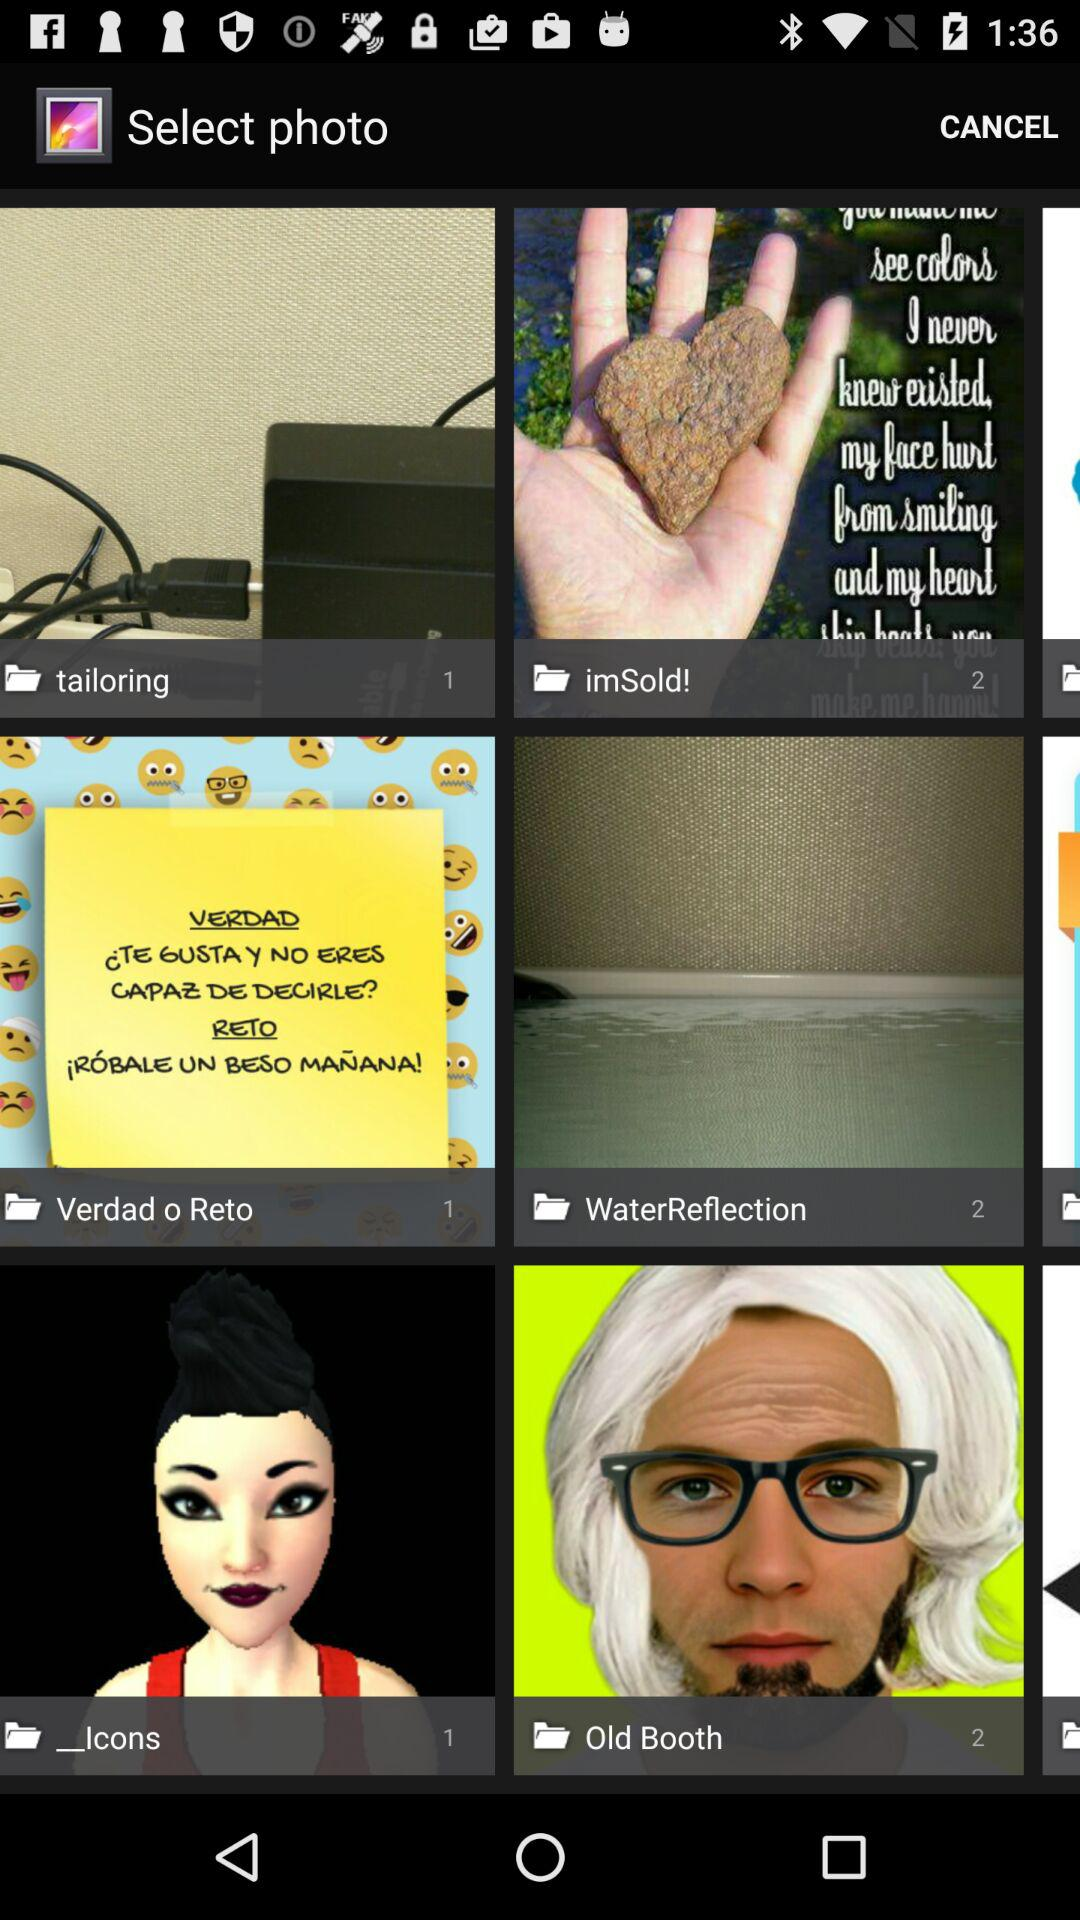How many pictures are in the "WaterReflection" folder? There are 2 pictures. 